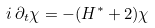Convert formula to latex. <formula><loc_0><loc_0><loc_500><loc_500>i \, \partial _ { t } \chi = - ( H ^ { * } + 2 ) \chi</formula> 